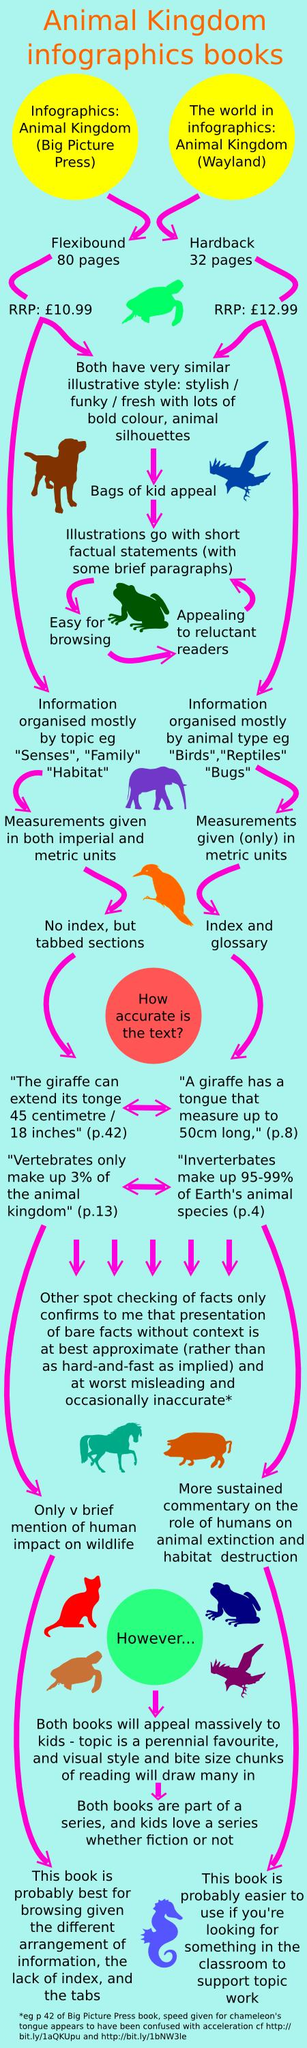List a handful of essential elements in this visual. The hardback cover of the book "Animal Kingdom" has 32 pages. The price of a book published by Big Picture Press in pounds is 10.99. 